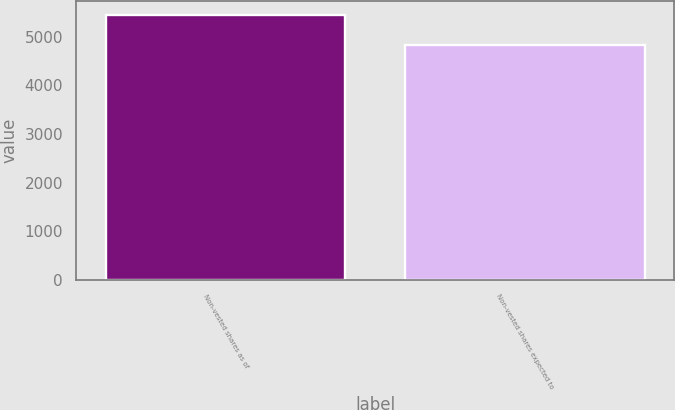Convert chart. <chart><loc_0><loc_0><loc_500><loc_500><bar_chart><fcel>Non-vested shares as of<fcel>Non-vested shares expected to<nl><fcel>5457<fcel>4832<nl></chart> 